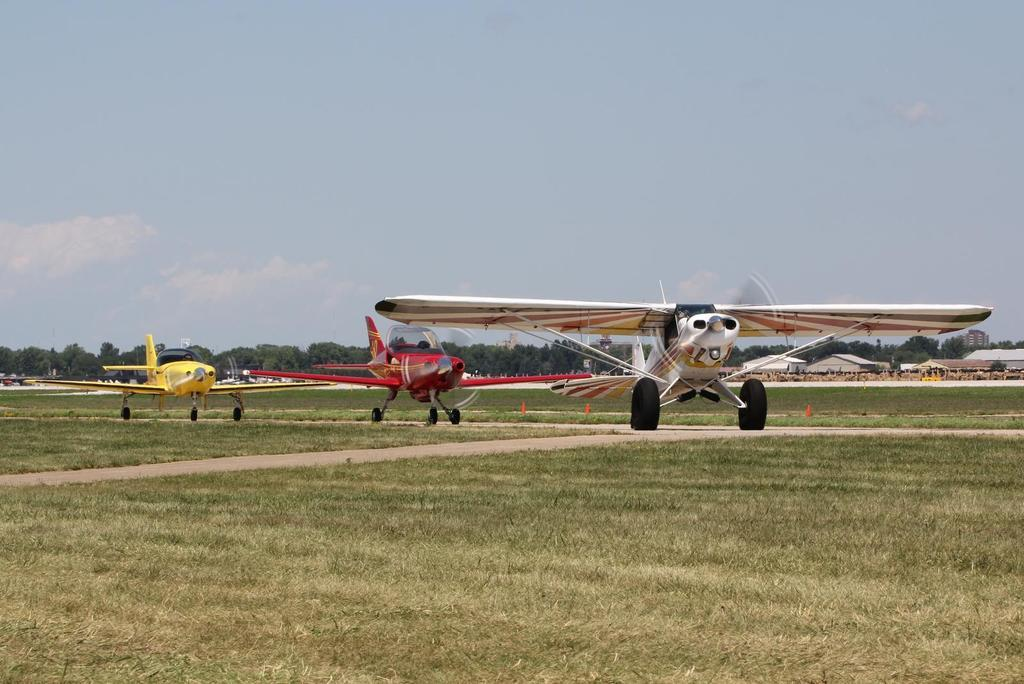What can be seen on the runway in the image? There are aeroplanes on the runway in the image. What is visible in the background of the image? There are buildings, trees, and the sky visible in the background of the image. What is the condition of the sky in the image? The sky is visible in the background, and clouds are present in the sky. What type of vegetation is at the bottom of the image? There is grass at the bottom of the image. Can you tell me how many drums are being played by the aeroplanes in the image? There are no drums present in the image; it features aeroplanes on a runway. On which side of the image are the buildings located? The buildings are located in the background of the image, so it is not accurate to describe them as being on a specific side. 